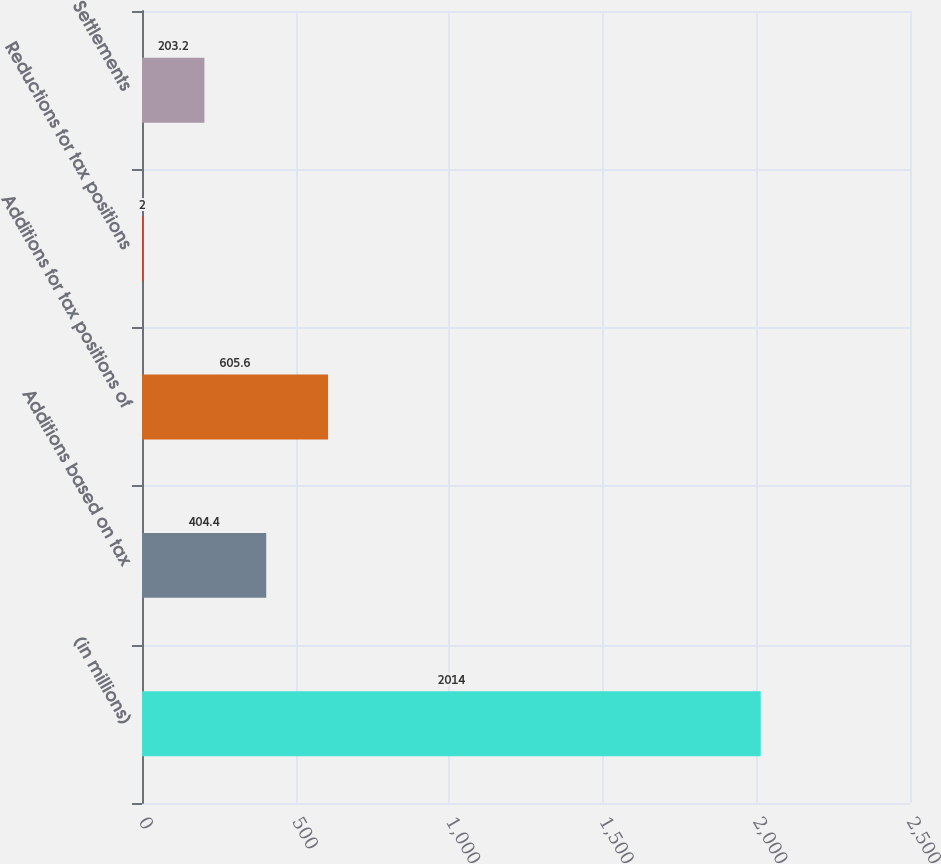Convert chart. <chart><loc_0><loc_0><loc_500><loc_500><bar_chart><fcel>(in millions)<fcel>Additions based on tax<fcel>Additions for tax positions of<fcel>Reductions for tax positions<fcel>Settlements<nl><fcel>2014<fcel>404.4<fcel>605.6<fcel>2<fcel>203.2<nl></chart> 